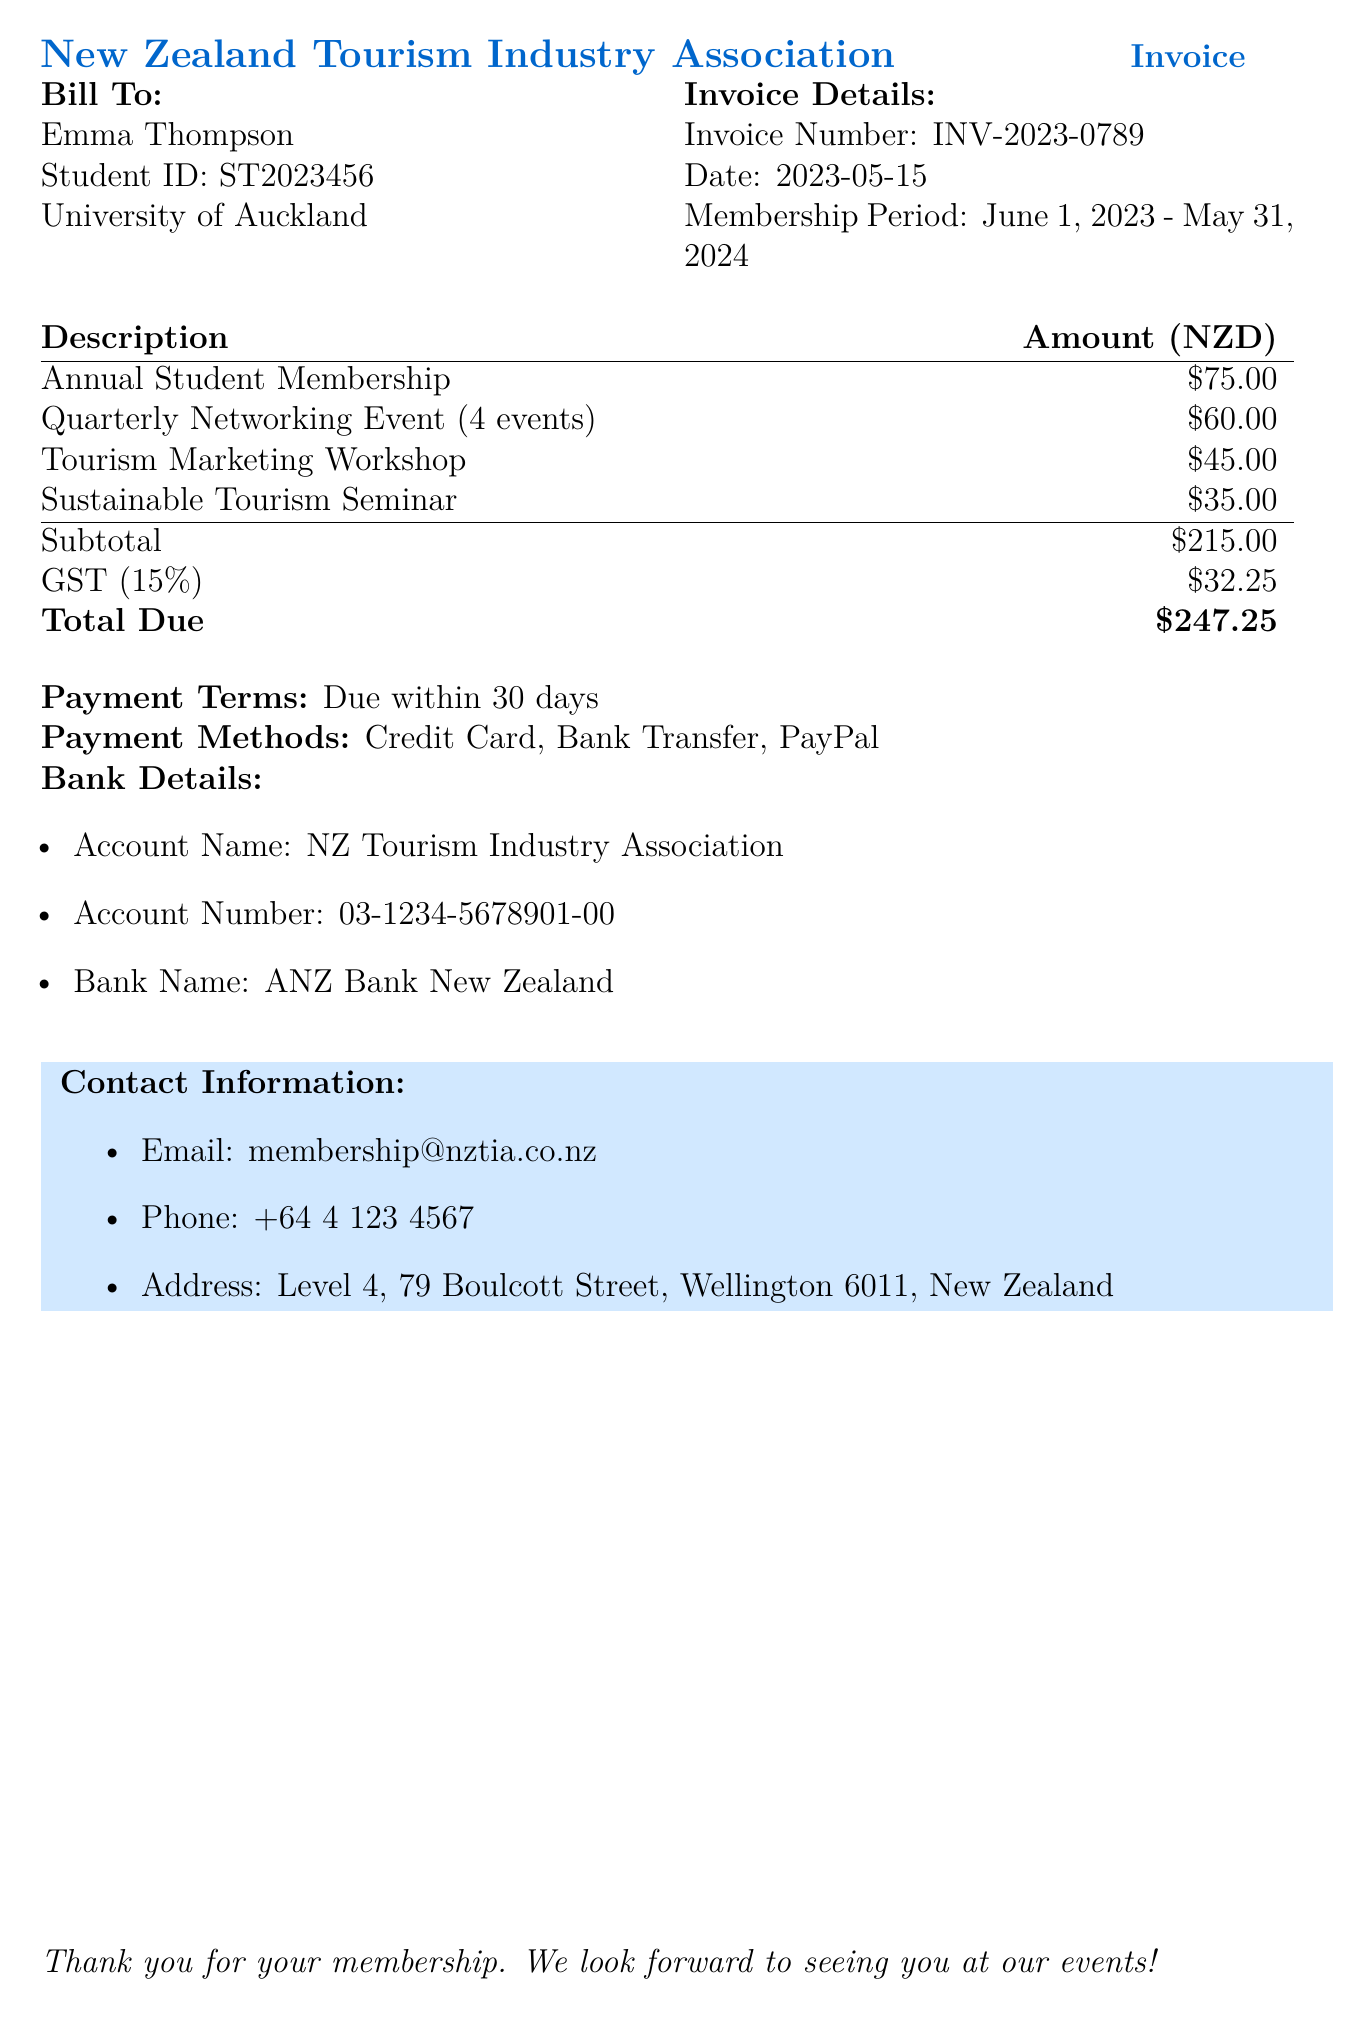What is the invoice number? The invoice number is provided in the details section of the document and is a unique identifier for the invoice.
Answer: INV-2023-0789 What is the total amount due? The total amount due is listed at the bottom of the invoice, which includes all fees and tax.
Answer: $247.25 Who is the bill addressed to? The bill is addressed to the individual whose name appears at the top of the billing section.
Answer: Emma Thompson What is the membership period? The membership period specifies the duration for which the membership is valid, as stated in the document.
Answer: June 1, 2023 - May 31, 2024 How much is the GST charged? The GST amount is calculated as a percentage of the subtotal and is specifically mentioned in the billing details.
Answer: $32.25 What is the fee for the Sustainable Tourism Seminar? The fee for the Sustainable Tourism Seminar is listed alongside the other workshop fees in the description table.
Answer: $35.00 Are payments due immediately? The document specifies the payment terms related to the invoice's due date for payment.
Answer: Due within 30 days What payment methods are accepted? The document outlines the various payment methods available for settling the invoice.
Answer: Credit Card, Bank Transfer, PayPal How many quarterly networking events are included? The document indicates the number of networking events included in the invoice description.
Answer: 4 events 